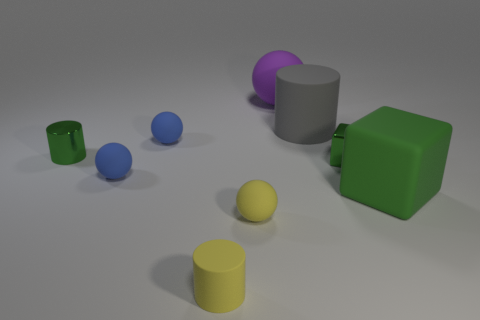Looking at the arrangement, could you guess the purpose of this setup? Given the varied shapes, materials, and colors, this setup appears to be a demonstration or an experimental arrangement, possibly for educational purposes, such as teaching about geometry, material properties, or photography composition. 